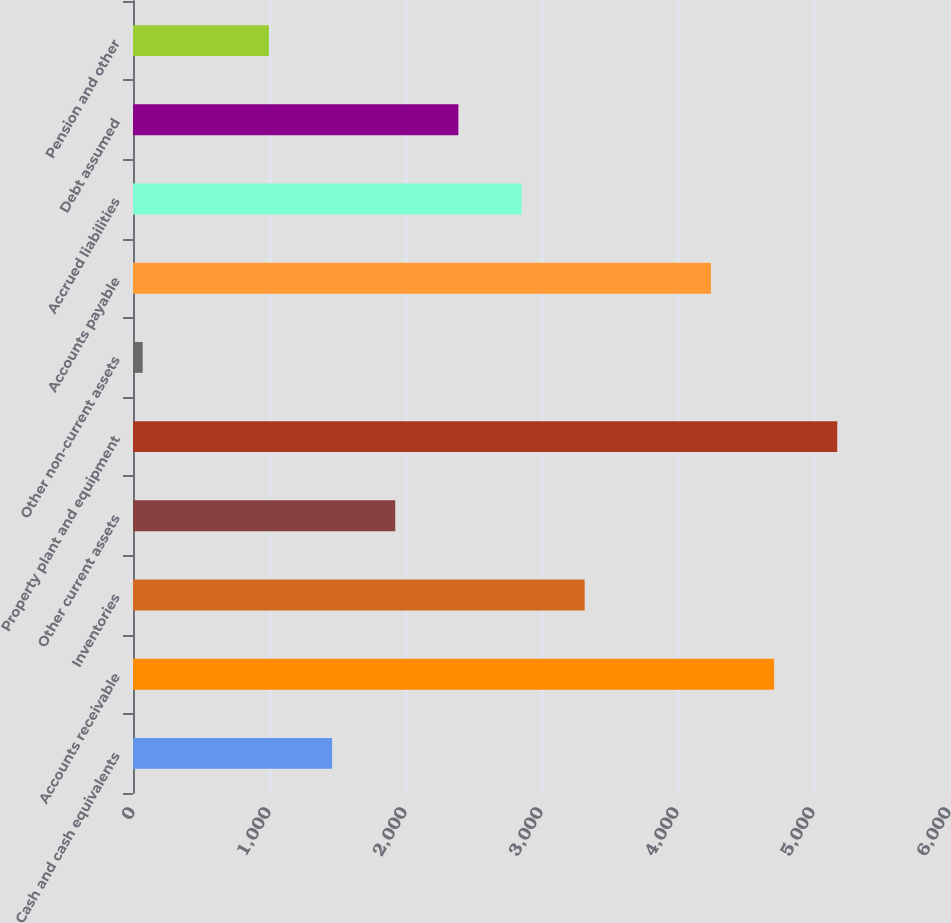Convert chart. <chart><loc_0><loc_0><loc_500><loc_500><bar_chart><fcel>Cash and cash equivalents<fcel>Accounts receivable<fcel>Inventories<fcel>Other current assets<fcel>Property plant and equipment<fcel>Other non-current assets<fcel>Accounts payable<fcel>Accrued liabilities<fcel>Debt assumed<fcel>Pension and other<nl><fcel>1463.9<fcel>4714<fcel>3321.1<fcel>1928.2<fcel>5178.3<fcel>71<fcel>4249.7<fcel>2856.8<fcel>2392.5<fcel>999.6<nl></chart> 